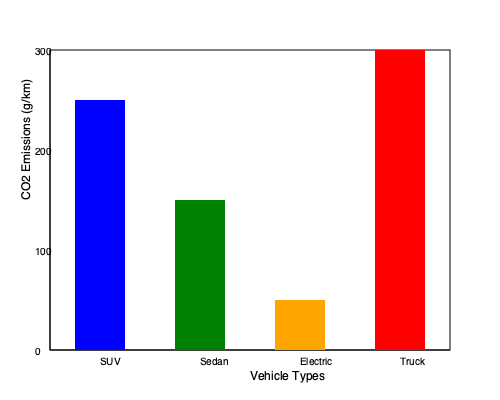Based on the bar graph showing CO2 emissions for different vehicle types, calculate the total reduction in carbon footprint if 100 truck owners switched to electric vehicles. Express your answer in grams of CO2 per kilometer. To solve this problem, we need to follow these steps:

1. Identify the CO2 emissions for trucks and electric vehicles from the graph:
   - Trucks: 300 g/km (red bar)
   - Electric vehicles: 50 g/km (orange bar)

2. Calculate the difference in emissions between trucks and electric vehicles:
   $$ 300 \text{ g/km} - 50 \text{ g/km} = 250 \text{ g/km} $$

3. Multiply the difference by the number of truck owners switching:
   $$ 250 \text{ g/km} \times 100 \text{ owners} = 25,000 \text{ g/km} $$

Therefore, if 100 truck owners switched to electric vehicles, the total reduction in carbon footprint would be 25,000 g/km.
Answer: 25,000 g/km 